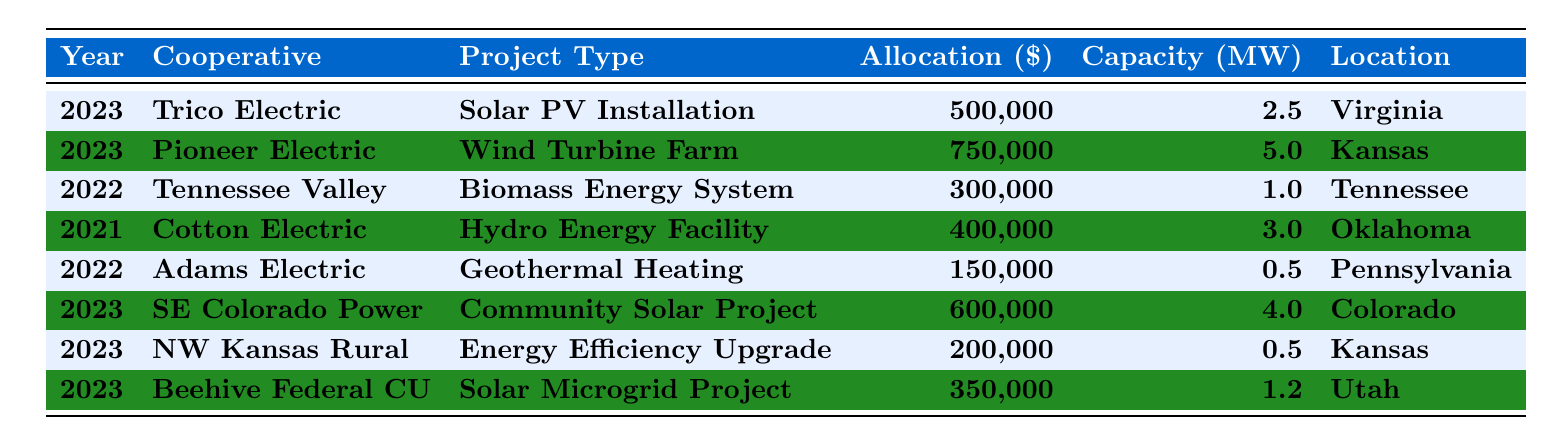What is the total funding allocated to renewable energy projects in 2023? In 2023, the allocated amounts are 500,000 (Trico Electric), 750,000 (Pioneer Electric), 600,000 (Southeast Colorado Power Association), 200,000 (Northwest Kansas Rural), and 350,000 (Beehive Federal Credit Union). Adding these amounts gives 500,000 + 750,000 + 600,000 + 200,000 + 350,000 = 2,400,000.
Answer: 2,400,000 Which cooperative received funding for a wind turbine farm? The table indicates that Pioneer Electric Cooperative received funding for a wind turbine farm. This is directly listed under the Project Type for this cooperative.
Answer: Pioneer Electric Cooperative What is the capacity of the biomass energy project by Tennessee Valley Electric Cooperative? The capacity for the biomass energy project listed for 2022 under Tennessee Valley Electric Cooperative is 1 MW, which is explicitly shown in the table.
Answer: 1 MW How many projects received funding from the USDA REAP Grant? The only project receiving funding from the USDA REAP Grant is the Solar PV Installation by Trico Electric Cooperative in 2023, as seen in the Funding Source column.
Answer: 1 What is the average allocation amount for renewable energy projects in 2022? In 2022, the allocation amounts are 300,000 (Tennessee Valley), and 150,000 (Adams Electric). The total is 300,000 + 150,000 = 450,000. Since there are 2 projects, the average is 450,000 / 2 = 225,000.
Answer: 225,000 Did any cooperative receive funding for geothermal heating? Yes, Adams Electric Cooperative received funding for geothermal heating as listed in the table.
Answer: Yes What is the difference in funding between the highest and lowest funded projects in 2023? The highest funded project in 2023 is the wind turbine farm by Pioneer Electric with 750,000. The lowest is the energy efficiency upgrade by Northwest Kansas Rural with 200,000. The difference is 750,000 - 200,000 = 550,000.
Answer: 550,000 Which state has the least amount of funding allocated to renewable energy projects? The project with the least funding listed is the Geothermal Heating for Adams Electric Cooperative in Pennsylvania, with an allocation of 150,000. This indicates it has the lowest funding among project allocations.
Answer: Pennsylvania What was the total capacity (in MW) of projects funded in Kansas? The projects funded in Kansas are the Wind Turbine Farm (5 MW by Pioneer Electric) and the Energy Efficiency Upgrade (0.5 MW by Northwest Kansas Rural). Their total capacity is 5 + 0.5 = 5.5 MW.
Answer: 5.5 MW Which cooperative received funding for a hydro energy facility in 2021? The Cotton Electric Cooperative received funding for a hydro energy facility in 2021 as stated specifically under the Project Type.
Answer: Cotton Electric Cooperative 